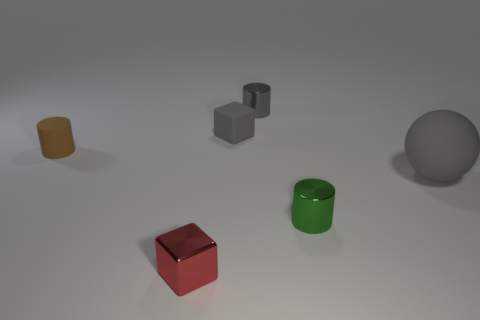There is a metal object that is on the left side of the small cube that is behind the large object that is behind the small metal block; what is its shape?
Keep it short and to the point. Cube. Are there more things in front of the tiny green object than brown metal spheres?
Keep it short and to the point. Yes. There is a small metallic object that is right of the small gray metal thing; is its shape the same as the tiny gray metal thing?
Provide a succinct answer. Yes. What is the material of the big sphere that is to the right of the small gray matte cube?
Your answer should be compact. Rubber. How many other tiny objects are the same shape as the small green object?
Provide a short and direct response. 2. There is a small cylinder that is on the left side of the metallic thing that is behind the tiny brown rubber thing; what is its material?
Provide a short and direct response. Rubber. What is the shape of the small rubber object that is the same color as the large matte object?
Offer a terse response. Cube. Is there a red sphere that has the same material as the gray block?
Keep it short and to the point. No. What is the shape of the big matte thing?
Ensure brevity in your answer.  Sphere. What number of tiny cyan metal things are there?
Provide a succinct answer. 0. 